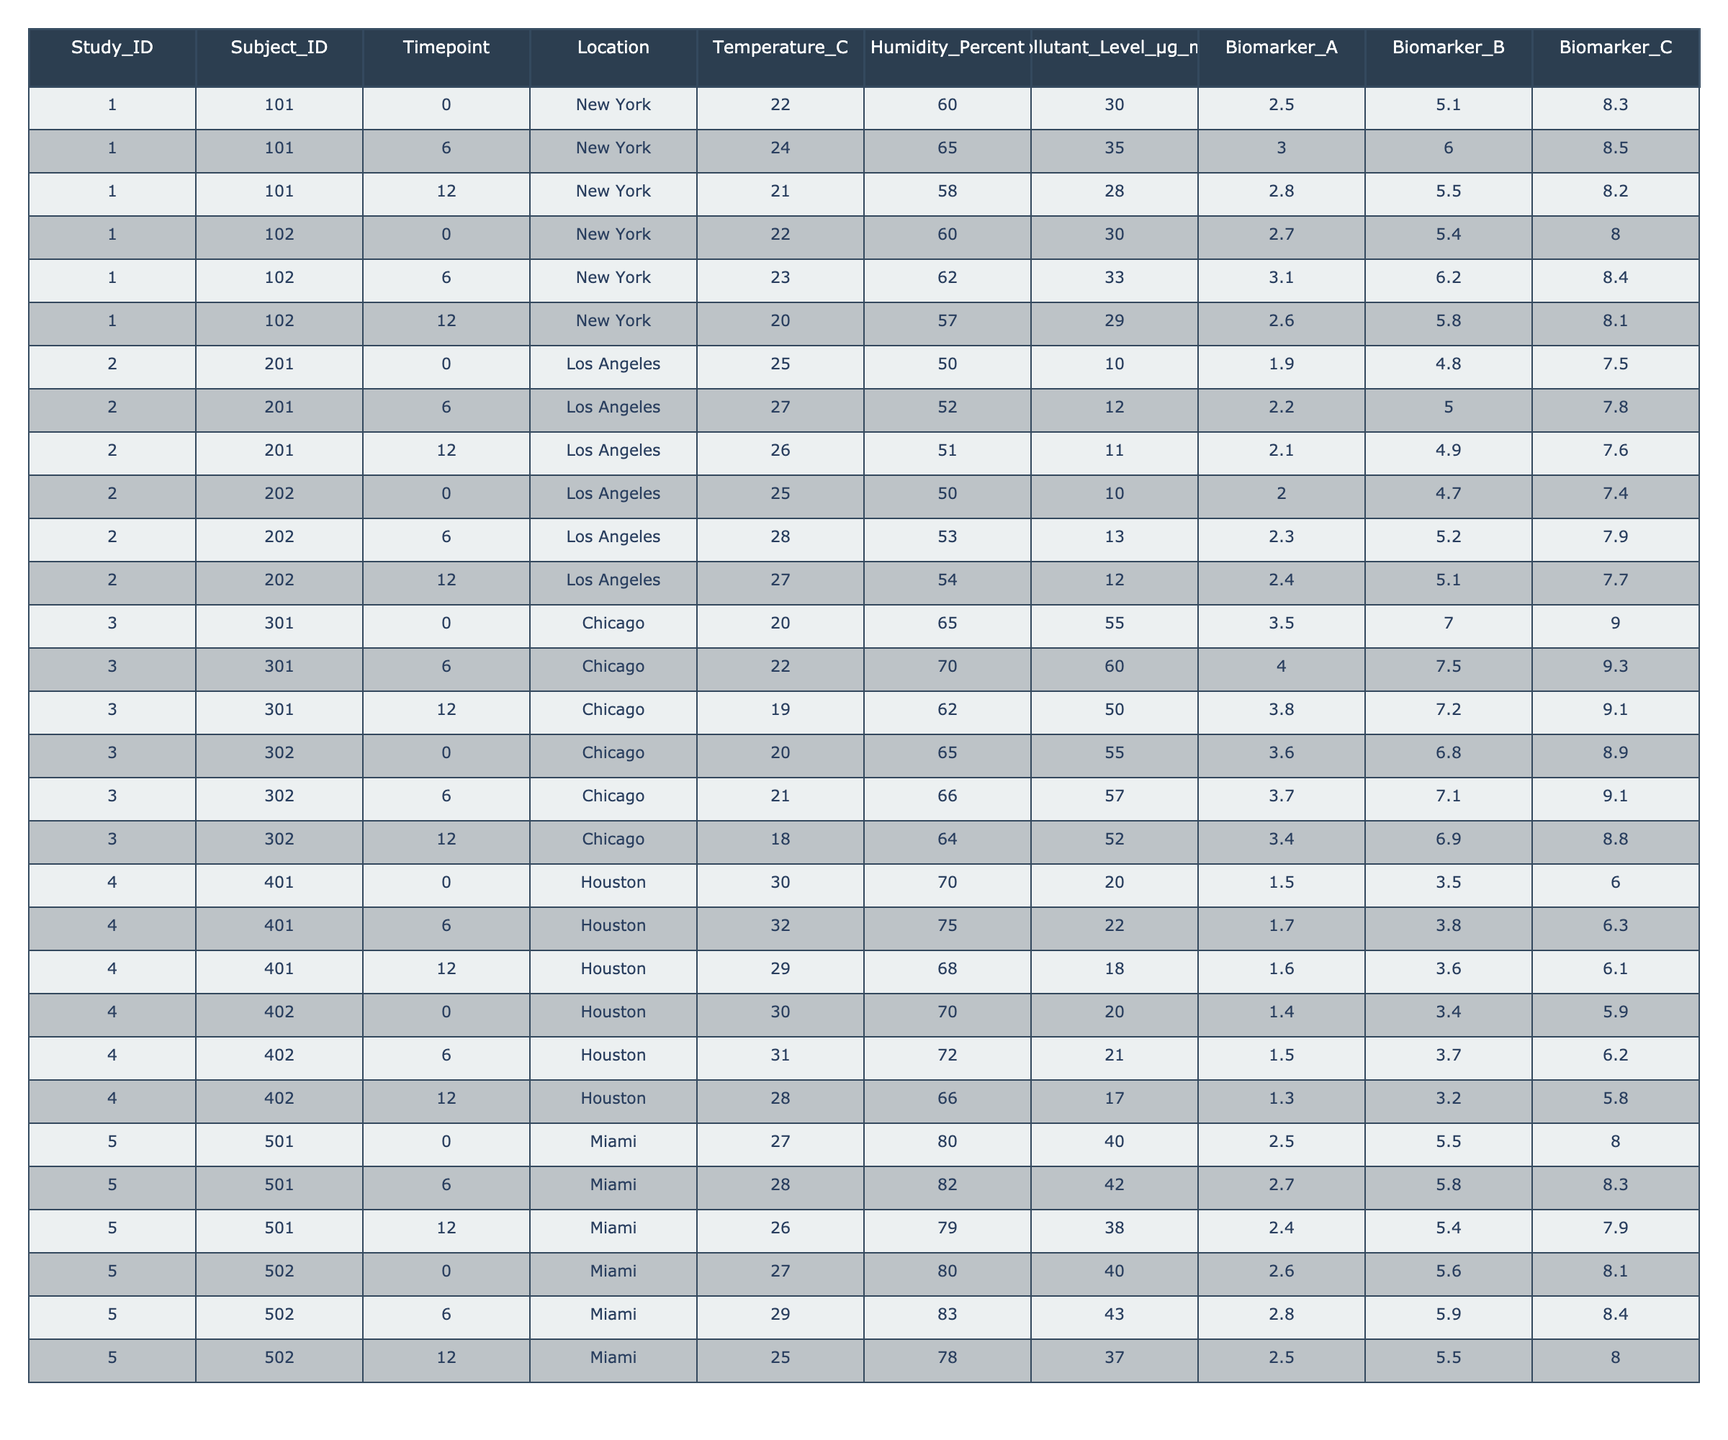what is the maximum level of Biomarker A observed in the study? Looking at the values under Biomarker A, the highest value recorded is 4.0 observed in Chicago at timepoint 6 for subject 301.
Answer: 4.0 what is the average temperature in Miami across all time points? The temperatures in Miami are 27, 28, 26, 27, 29, and 25 degrees Celsius. The average is calculated by summing these values (27 + 28 + 26 + 27 + 29 + 25 = 162) and dividing by 6, which gives 162/6 = 27.
Answer: 27 how many subjects were studied in Los Angeles? The data shows that there are two unique Subject_IDs (201 and 202) recorded in Los Angeles across the timepoints.
Answer: 2 what was the humidity level at timepoint 12 for the subject from Houston with ID 401? Referring to the table, at timepoint 12 for the subject from Houston with ID 401, the humidity level is 68 percent.
Answer: 68 is the pollutant level consistently higher in Chicago compared to Miami? To assess, we compare the average pollutant levels: Chicago's levels are 55, 60, 50, 55, 57, and 52 µg/m3 (average = 54.67), while Miami's levels are 40, 42, 38, 40, 43, and 37 µg/m3 (average = 40). Therefore, Chicago has higher levels.
Answer: Yes what is the change in Biomarker C for subject 501 from timepoint 0 to timepoint 12? For subject 501, the value of Biomarker C at timepoint 0 is 8.0, and at timepoint 12 it is 7.9. The change is calculated as 7.9 - 8.0 = -0.1, indicating a decrease.
Answer: -0.1 which location has the highest average humidity across all timepoints? The average humidities to compare are: New York (61.00), Los Angeles (51.67), Chicago (65.33), Houston (70.00), and Miami (80.00). Miami has the highest average humidity at 80.
Answer: Miami what is the difference in Biomarker B between the highest and lowest timepoints for subject 302? Subject 302 has Biomarker B values of 6.8, 7.1, and 6.9 at timepoints 0, 6, and 12, respectively. The maximum is 7.1 and the minimum is 6.8, hence the difference is 7.1 - 6.8 = 0.3.
Answer: 0.3 how many total timepoints were measured in the study and what is the average temperature during these timepoints? The total timepoints measured in the study is 3 for each subject. The temperature observed across all subjects can be summed: (22 + 24 + 21 + 22 + 23 + 20 + 25 + 27 + 26 + 25 + 28 + 27 + 30 + 32 + 29 + 30 + 31 + 28 + 27 + 28 + 26 + 29 + 25) = 641, and dividing this by 30 gives an average of approximately 24.1.
Answer: 24.1 was there any timepoint where the Biomarker A level dropped below 2.5? Reviewing the data for Biomarker A, the lowest value is 1.3, which occurs for subject 402 at timepoint 12 in Houston, confirming a drop below 2.5.
Answer: Yes 